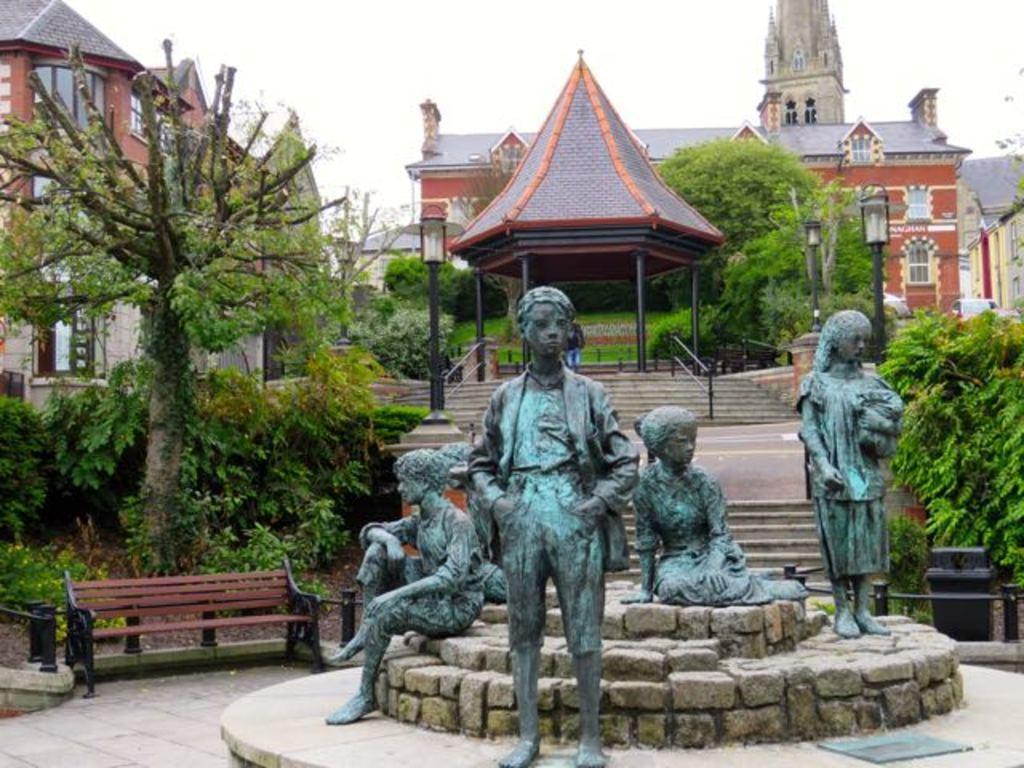Please provide a concise description of this image. In this image there are stones arranged in round shape. On that there are statues. In the back there is a bench. Also there are steps. And there are trees and light poles. And there are buildings with windows. And there is a shed with poles. In the background there is sky. 